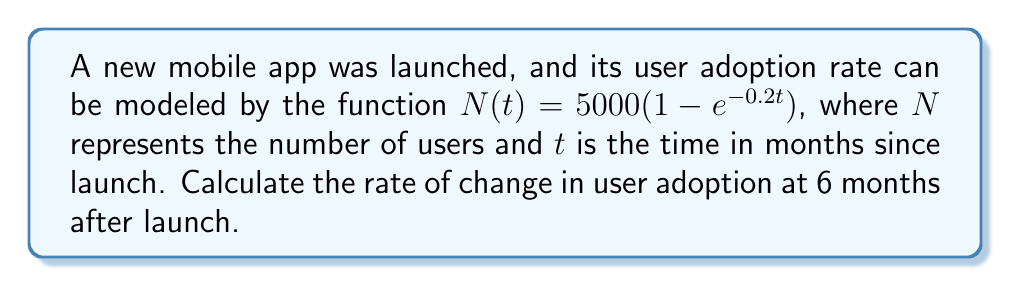Help me with this question. To find the rate of change in user adoption at 6 months, we need to calculate the derivative of $N(t)$ and evaluate it at $t = 6$. Let's break this down step-by-step:

1. Given function: $N(t) = 5000(1 - e^{-0.2t})$

2. To find the rate of change, we need to calculate $\frac{dN}{dt}$:
   $$\frac{dN}{dt} = 5000 \cdot \frac{d}{dt}(1 - e^{-0.2t})$$
   $$= 5000 \cdot (-1) \cdot \frac{d}{dt}(e^{-0.2t})$$
   $$= -5000 \cdot e^{-0.2t} \cdot (-0.2)$$
   $$= 1000e^{-0.2t}$$

3. Now we have the rate of change function: $\frac{dN}{dt} = 1000e^{-0.2t}$

4. To find the rate of change at 6 months, we substitute $t = 6$:
   $$\frac{dN}{dt}\bigg|_{t=6} = 1000e^{-0.2(6)}$$
   $$= 1000e^{-1.2}$$
   $$\approx 301.19$$

This result represents the number of new users being added per month at the 6-month mark.
Answer: 301.19 users/month 